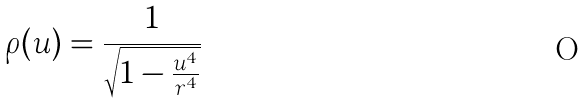Convert formula to latex. <formula><loc_0><loc_0><loc_500><loc_500>\rho ( u ) = \frac { 1 } { \sqrt { 1 - \frac { u ^ { 4 } } { r ^ { 4 } } } }</formula> 